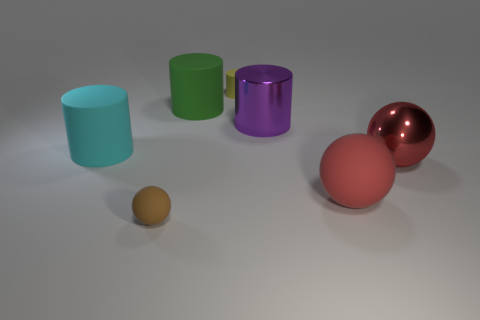There is a tiny rubber thing that is on the right side of the large object that is behind the big purple shiny thing; what number of cylinders are to the left of it?
Give a very brief answer. 2. Are there any small things to the right of the big green thing?
Offer a terse response. Yes. What number of small yellow things have the same material as the small brown thing?
Your answer should be very brief. 1. What number of things are small cylinders or cyan metal spheres?
Offer a terse response. 1. Is there a small purple rubber cube?
Your response must be concise. No. The thing that is left of the small rubber object in front of the small object behind the tiny brown rubber object is made of what material?
Your answer should be very brief. Rubber. Is the number of red balls that are left of the big cyan rubber thing less than the number of big matte things?
Keep it short and to the point. Yes. There is a object that is the same size as the brown rubber sphere; what is it made of?
Provide a succinct answer. Rubber. There is a cylinder that is both right of the green thing and behind the purple object; how big is it?
Keep it short and to the point. Small. There is another matte thing that is the same shape as the brown matte thing; what size is it?
Your response must be concise. Large. 